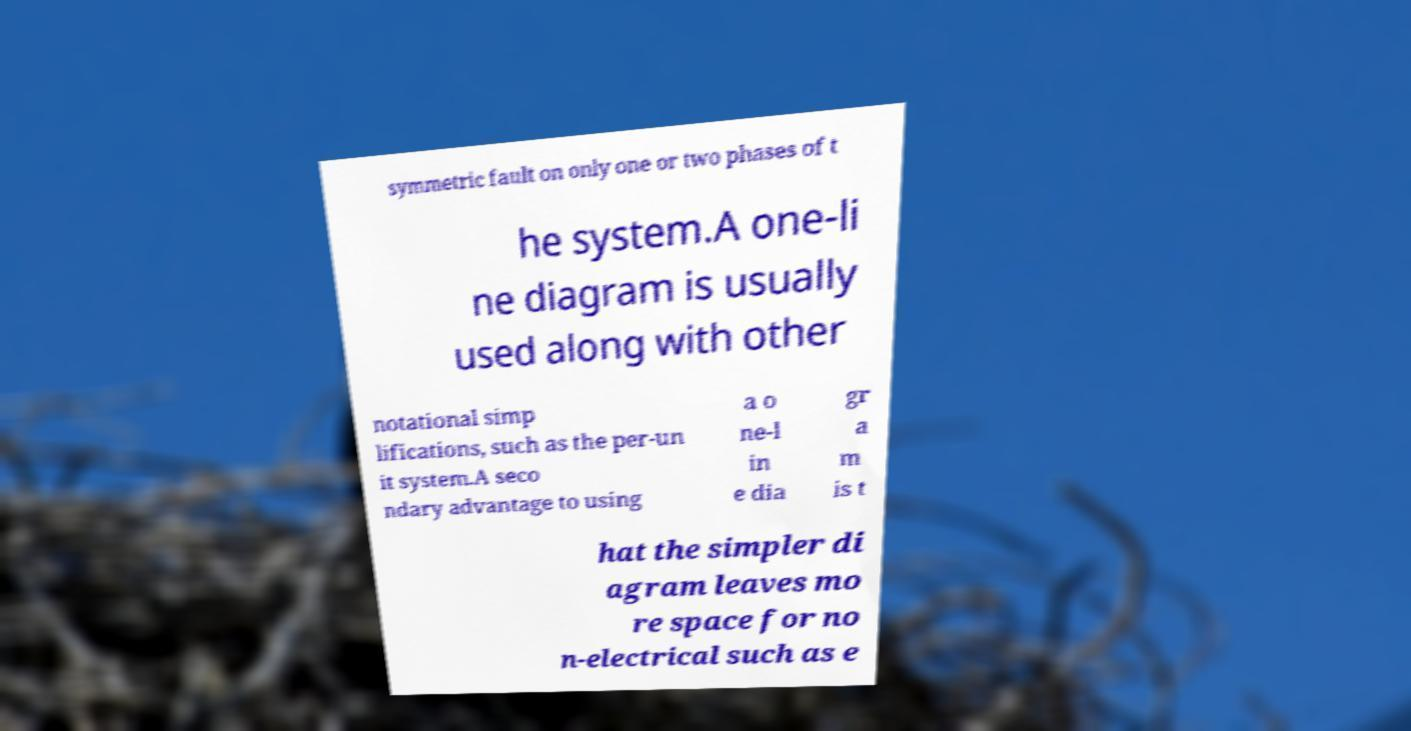Could you assist in decoding the text presented in this image and type it out clearly? symmetric fault on only one or two phases of t he system.A one-li ne diagram is usually used along with other notational simp lifications, such as the per-un it system.A seco ndary advantage to using a o ne-l in e dia gr a m is t hat the simpler di agram leaves mo re space for no n-electrical such as e 